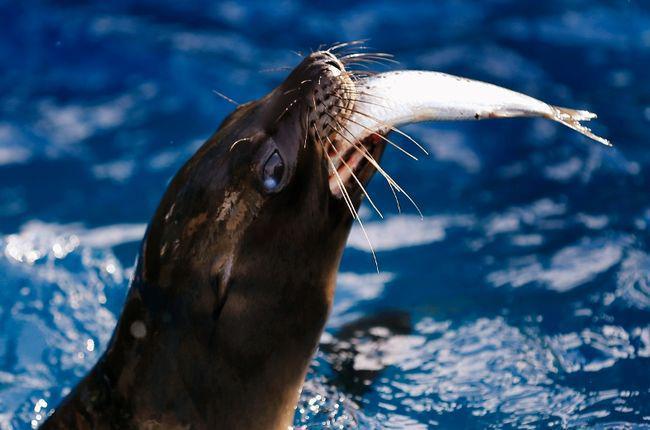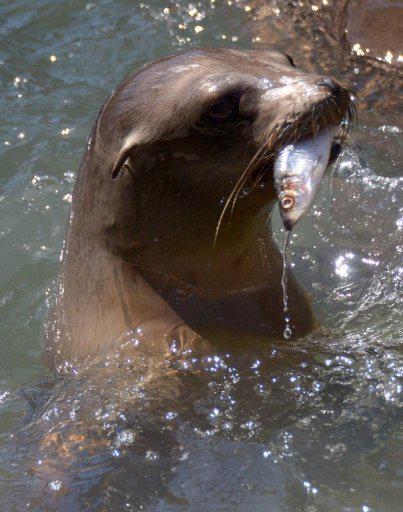The first image is the image on the left, the second image is the image on the right. Given the left and right images, does the statement "Each image shows one seal with its head out of water and a fish caught in its mouth, and the seals in the left and right images face the same direction." hold true? Answer yes or no. Yes. The first image is the image on the left, the second image is the image on the right. Examine the images to the left and right. Is the description "There is a seal in the water while feeding on a fish in the center of both images" accurate? Answer yes or no. Yes. 